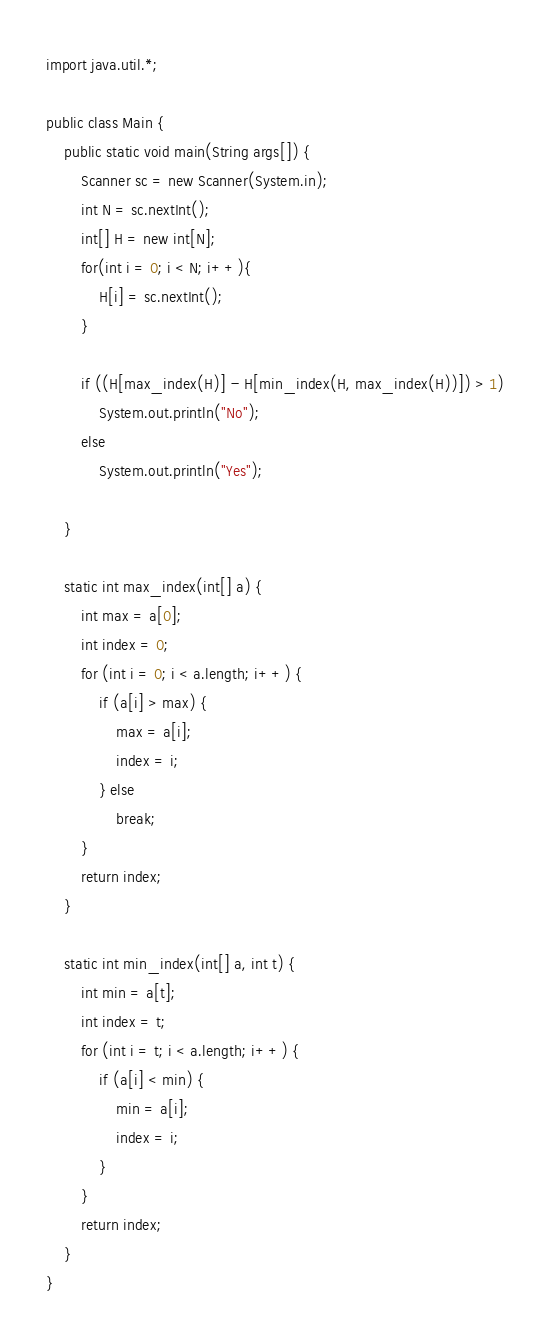<code> <loc_0><loc_0><loc_500><loc_500><_Java_>import java.util.*;

public class Main {
    public static void main(String args[]) {
        Scanner sc = new Scanner(System.in);
        int N = sc.nextInt();
        int[] H = new int[N];
        for(int i = 0; i < N; i++){
            H[i] = sc.nextInt();
        }

        if ((H[max_index(H)] - H[min_index(H, max_index(H))]) > 1)
            System.out.println("No");
        else
            System.out.println("Yes");
        
    }

    static int max_index(int[] a) {
        int max = a[0];
        int index = 0;
        for (int i = 0; i < a.length; i++) {
            if (a[i] > max) {
                max = a[i];
                index = i;
            } else
                break;
        }
        return index;
    }

    static int min_index(int[] a, int t) {
        int min = a[t];
        int index = t;
        for (int i = t; i < a.length; i++) {
            if (a[i] < min) {
                min = a[i];
                index = i;
            }
        }
        return index;
    }
}</code> 